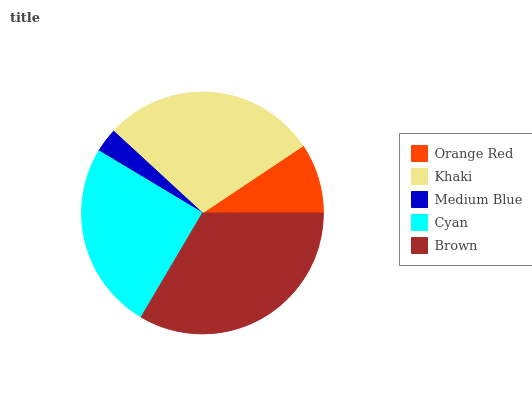Is Medium Blue the minimum?
Answer yes or no. Yes. Is Brown the maximum?
Answer yes or no. Yes. Is Khaki the minimum?
Answer yes or no. No. Is Khaki the maximum?
Answer yes or no. No. Is Khaki greater than Orange Red?
Answer yes or no. Yes. Is Orange Red less than Khaki?
Answer yes or no. Yes. Is Orange Red greater than Khaki?
Answer yes or no. No. Is Khaki less than Orange Red?
Answer yes or no. No. Is Cyan the high median?
Answer yes or no. Yes. Is Cyan the low median?
Answer yes or no. Yes. Is Medium Blue the high median?
Answer yes or no. No. Is Khaki the low median?
Answer yes or no. No. 